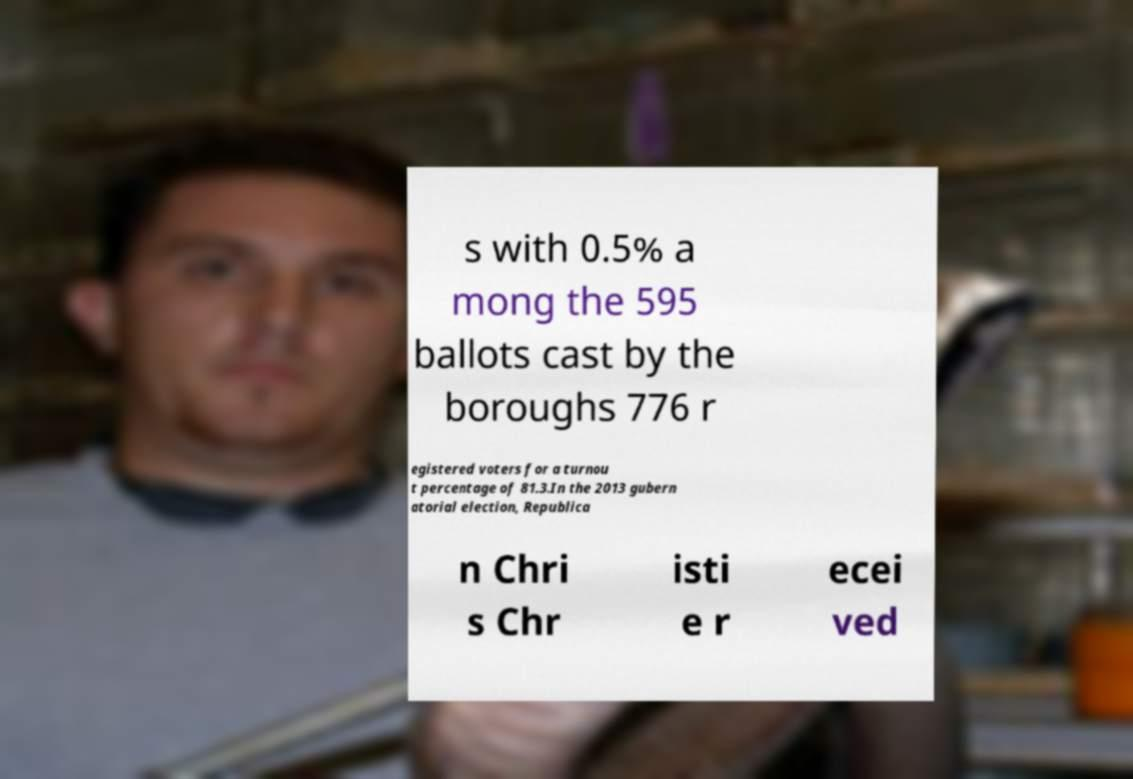What messages or text are displayed in this image? I need them in a readable, typed format. s with 0.5% a mong the 595 ballots cast by the boroughs 776 r egistered voters for a turnou t percentage of 81.3.In the 2013 gubern atorial election, Republica n Chri s Chr isti e r ecei ved 